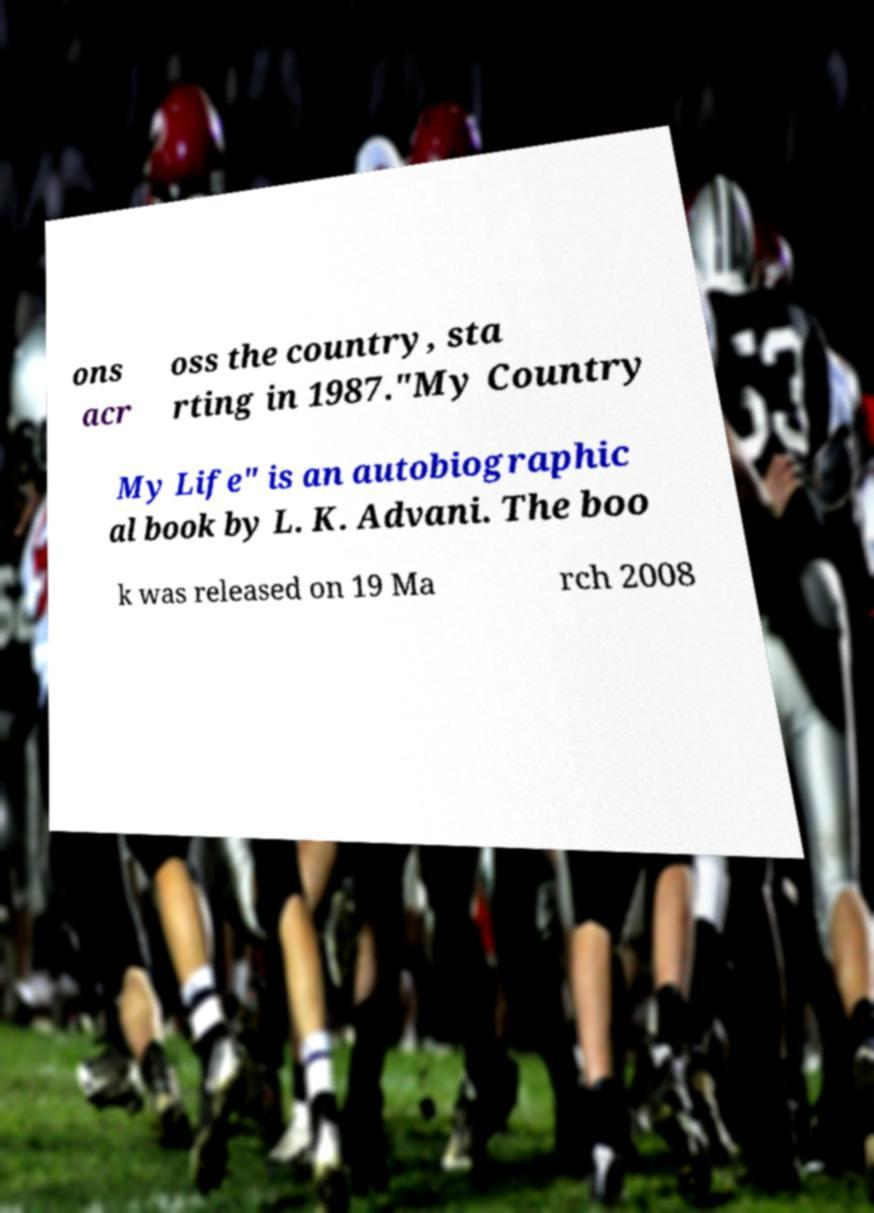I need the written content from this picture converted into text. Can you do that? ons acr oss the country, sta rting in 1987."My Country My Life" is an autobiographic al book by L. K. Advani. The boo k was released on 19 Ma rch 2008 